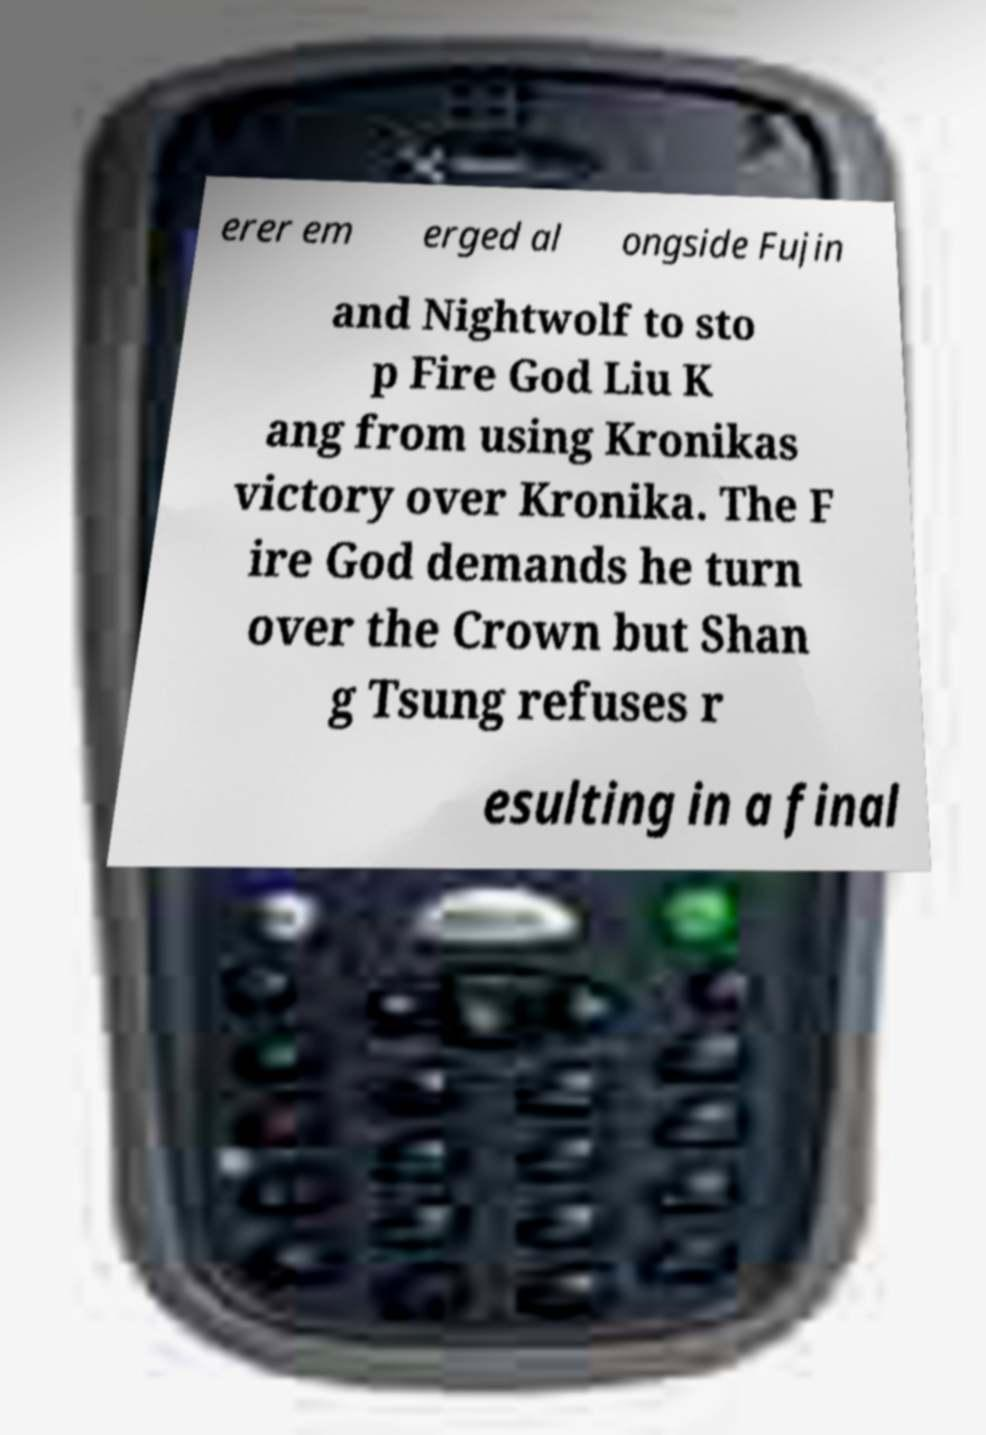What messages or text are displayed in this image? I need them in a readable, typed format. erer em erged al ongside Fujin and Nightwolf to sto p Fire God Liu K ang from using Kronikas victory over Kronika. The F ire God demands he turn over the Crown but Shan g Tsung refuses r esulting in a final 